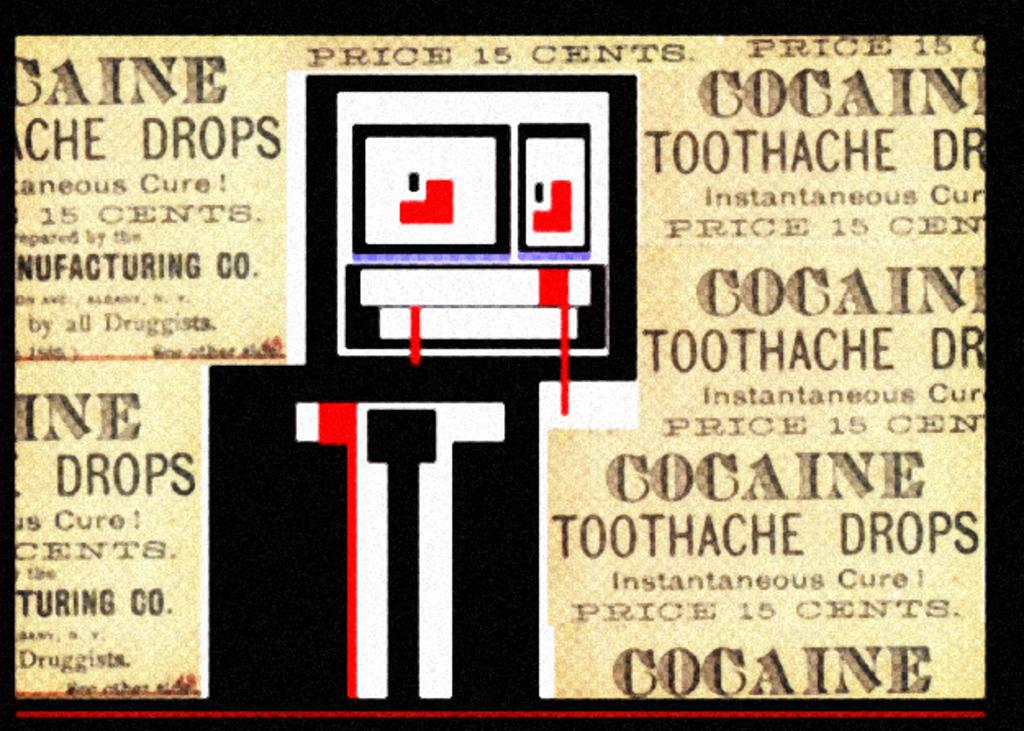<image>
Relay a brief, clear account of the picture shown. An advertisement for toothache drops that contain cocaine. 